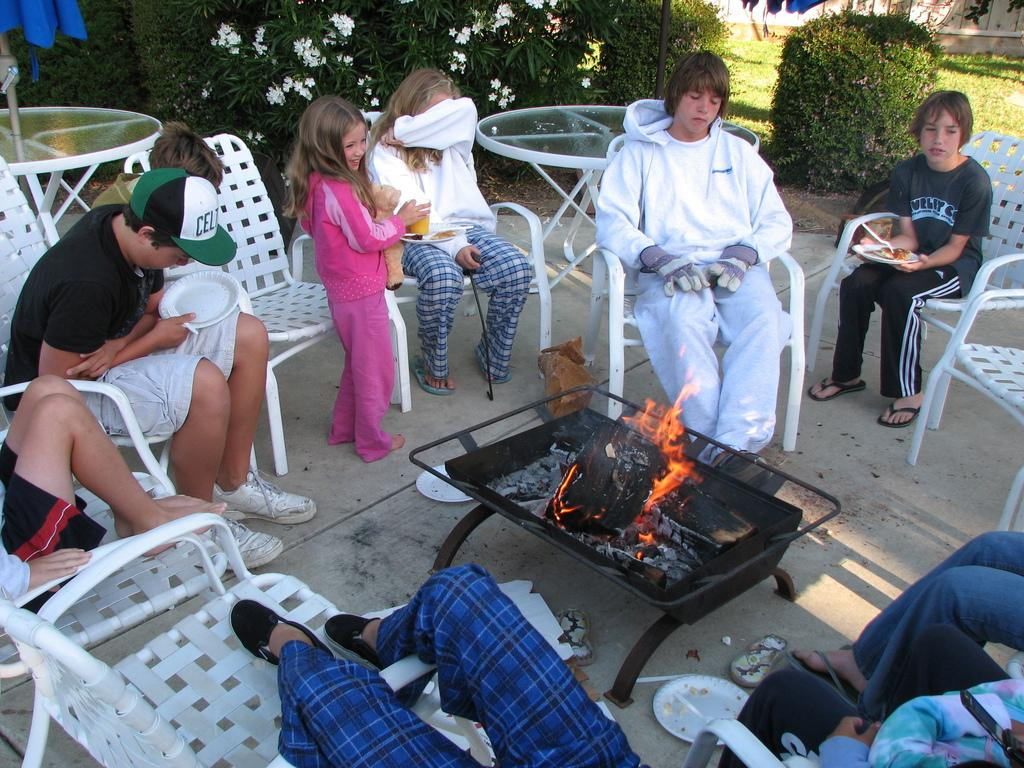Provide a one-sentence caption for the provided image. A family sits around the fire, including a teenager with a Celtics hat. 